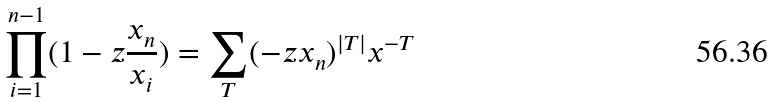<formula> <loc_0><loc_0><loc_500><loc_500>\prod _ { i = 1 } ^ { n - 1 } ( 1 - z \frac { x _ { n } } { x _ { i } } ) = \sum _ { T } ( - z x _ { n } ) ^ { | T | } x ^ { - T }</formula> 